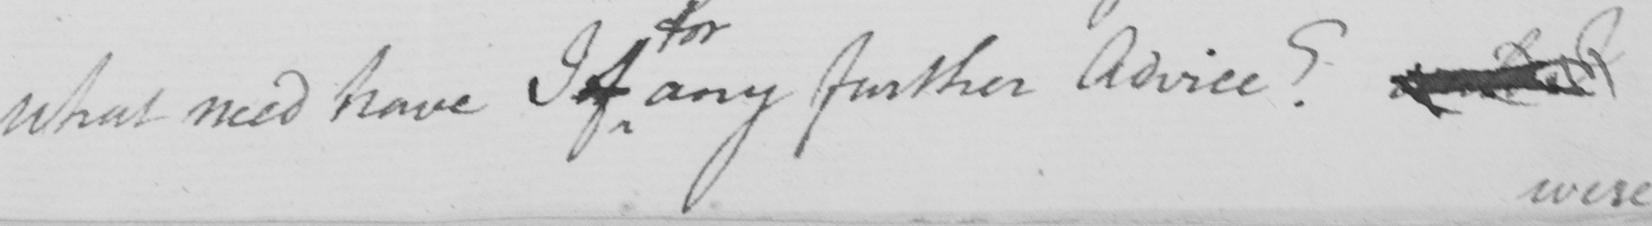Transcribe the text shown in this historical manuscript line. What need have I of any further Advice ?   <gap/> 